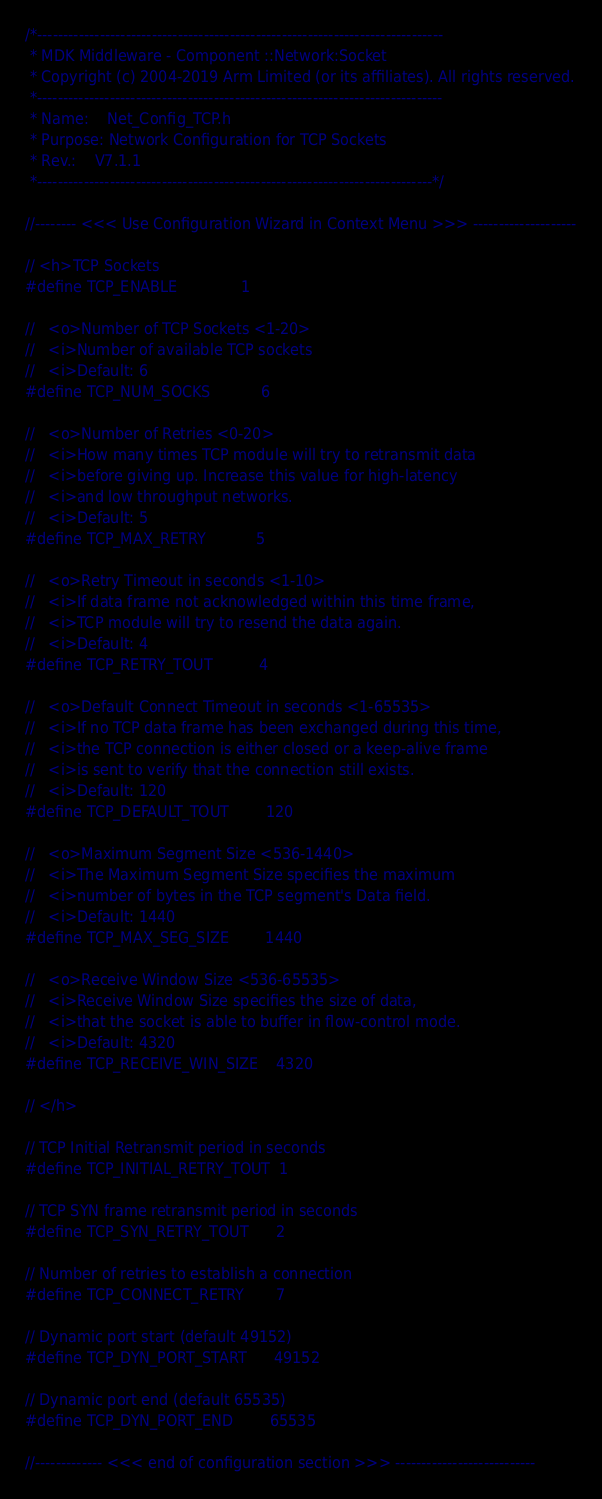Convert code to text. <code><loc_0><loc_0><loc_500><loc_500><_C_>/*------------------------------------------------------------------------------
 * MDK Middleware - Component ::Network:Socket
 * Copyright (c) 2004-2019 Arm Limited (or its affiliates). All rights reserved.
 *------------------------------------------------------------------------------
 * Name:    Net_Config_TCP.h
 * Purpose: Network Configuration for TCP Sockets
 * Rev.:    V7.1.1
 *----------------------------------------------------------------------------*/

//-------- <<< Use Configuration Wizard in Context Menu >>> --------------------

// <h>TCP Sockets
#define TCP_ENABLE              1

//   <o>Number of TCP Sockets <1-20>
//   <i>Number of available TCP sockets
//   <i>Default: 6
#define TCP_NUM_SOCKS           6

//   <o>Number of Retries <0-20>
//   <i>How many times TCP module will try to retransmit data
//   <i>before giving up. Increase this value for high-latency
//   <i>and low throughput networks.
//   <i>Default: 5
#define TCP_MAX_RETRY           5

//   <o>Retry Timeout in seconds <1-10>
//   <i>If data frame not acknowledged within this time frame,
//   <i>TCP module will try to resend the data again.
//   <i>Default: 4
#define TCP_RETRY_TOUT          4

//   <o>Default Connect Timeout in seconds <1-65535>
//   <i>If no TCP data frame has been exchanged during this time,
//   <i>the TCP connection is either closed or a keep-alive frame
//   <i>is sent to verify that the connection still exists.
//   <i>Default: 120
#define TCP_DEFAULT_TOUT        120

//   <o>Maximum Segment Size <536-1440>
//   <i>The Maximum Segment Size specifies the maximum
//   <i>number of bytes in the TCP segment's Data field.
//   <i>Default: 1440
#define TCP_MAX_SEG_SIZE        1440

//   <o>Receive Window Size <536-65535>
//   <i>Receive Window Size specifies the size of data, 
//   <i>that the socket is able to buffer in flow-control mode.
//   <i>Default: 4320
#define TCP_RECEIVE_WIN_SIZE    4320

// </h>

// TCP Initial Retransmit period in seconds
#define TCP_INITIAL_RETRY_TOUT  1

// TCP SYN frame retransmit period in seconds
#define TCP_SYN_RETRY_TOUT      2

// Number of retries to establish a connection
#define TCP_CONNECT_RETRY       7

// Dynamic port start (default 49152)
#define TCP_DYN_PORT_START      49152

// Dynamic port end (default 65535)
#define TCP_DYN_PORT_END        65535

//------------- <<< end of configuration section >>> ---------------------------
</code> 